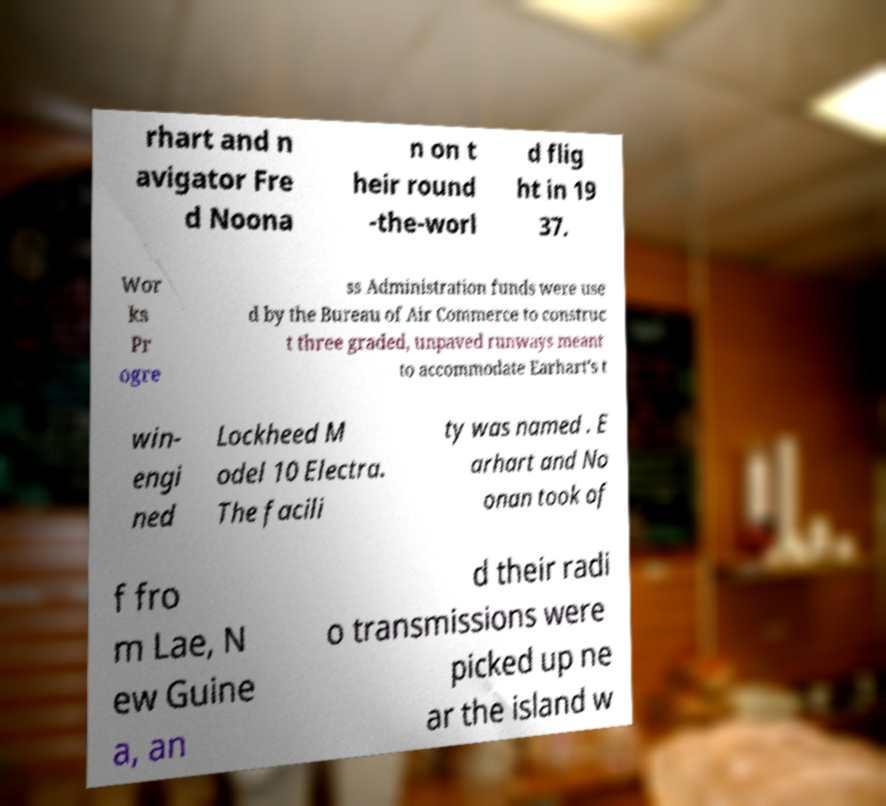What messages or text are displayed in this image? I need them in a readable, typed format. rhart and n avigator Fre d Noona n on t heir round -the-worl d flig ht in 19 37. Wor ks Pr ogre ss Administration funds were use d by the Bureau of Air Commerce to construc t three graded, unpaved runways meant to accommodate Earhart's t win- engi ned Lockheed M odel 10 Electra. The facili ty was named . E arhart and No onan took of f fro m Lae, N ew Guine a, an d their radi o transmissions were picked up ne ar the island w 